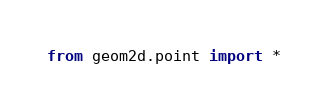Convert code to text. <code><loc_0><loc_0><loc_500><loc_500><_Python_>
from geom2d.point import *</code> 